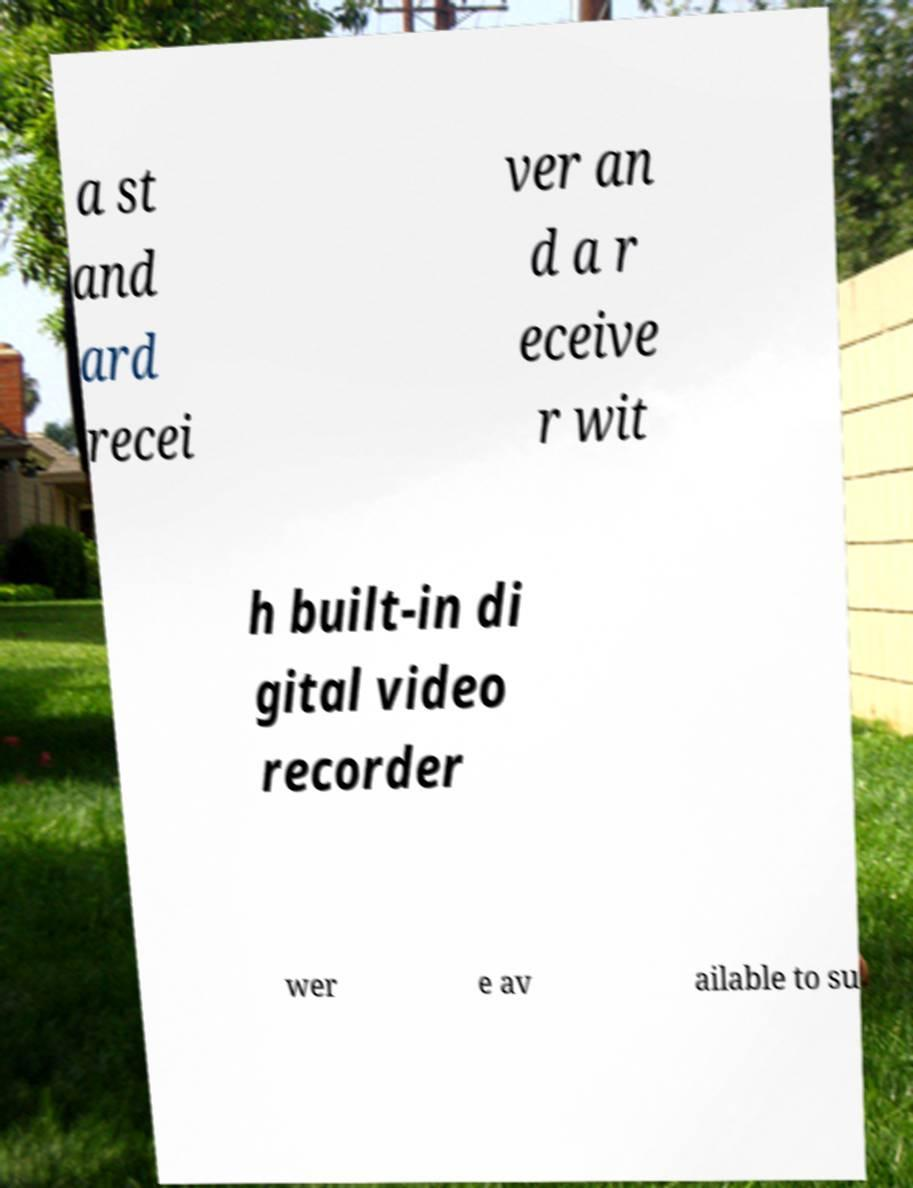Can you read and provide the text displayed in the image?This photo seems to have some interesting text. Can you extract and type it out for me? a st and ard recei ver an d a r eceive r wit h built-in di gital video recorder wer e av ailable to su 